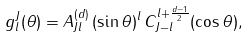Convert formula to latex. <formula><loc_0><loc_0><loc_500><loc_500>g ^ { J } _ { l } ( \theta ) = A ^ { ( d ) } _ { J l } \, ( \sin \theta ) ^ { l } \, C _ { J - l } ^ { l + \frac { d - 1 } { 2 } } ( \cos \theta ) ,</formula> 